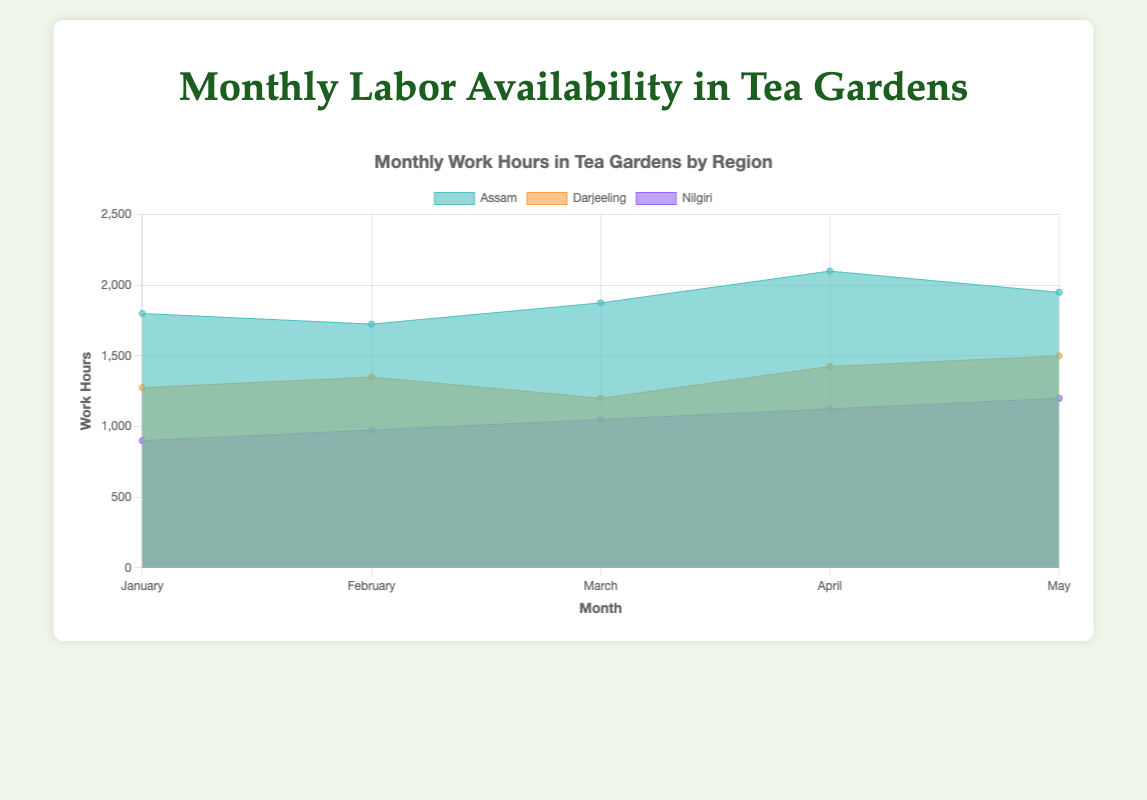Which region has the highest work hours in April? To find the answer, locate the data for April and compare the work hours for each region. Assam has 2100 work hours, Darjeeling has 1425, and Nilgiri has 1125. Assam has the highest work hours.
Answer: Assam What is the total number of work hours for Assam from January to May? Add the work hours for Assam across all months from January to May: 1800 (January) + 1725 (February) + 1875 (March) + 2100 (April) + 1950 (May). The total is 9450 work hours.
Answer: 9450 Which month had the lowest total labor across all regions? Add the total labor from all regions for each month and find the month with the minimum value: January (265), February (270), March (275), April (310), May (310). January has the lowest total labor.
Answer: January How do the work hours in Darjeeling compare between February and May? Find the work hours for Darjeeling in February and May: 1350 (February) and 1500 (May). Compare the two values. Darjeeling's work hours increased from February to May.
Answer: Increased What is the average work hours per month for Nilgiri? Add the work hours for Nilgiri across all months from January to May, then divide by the number of months: (900 + 975 + 1050 + 1125 + 1200) / 5. This results in 5250/5 = 1050 average work hours per month.
Answer: 1050 By how much did the total labor in Assam change from January to April? Subtract the labor count in January from the labor count in April for Assam: 140 (April) - 120 (January). The change is 20.
Answer: 20 During which month does Nilgiri have the most work hours? Compare work hours for Nilgiri across all months and find the maximum: January (900), February (975), March (1050), April (1125), May (1200). Nilgiri has the most work hours in May.
Answer: May Sum the total work hours for Darjeeling and Nilgiri in March. Add the work hours for Darjeeling and Nilgiri for March: 1200 (Darjeeling) + 1050 (Nilgiri). The total is 2250 work hours.
Answer: 2250 Which region had the smallest labor force in February? Compare the labor forces for all regions in February: Assam (115), Darjeeling (90), and Nilgiri (65). Nilgiri has the smallest labor force.
Answer: Nilgiri 